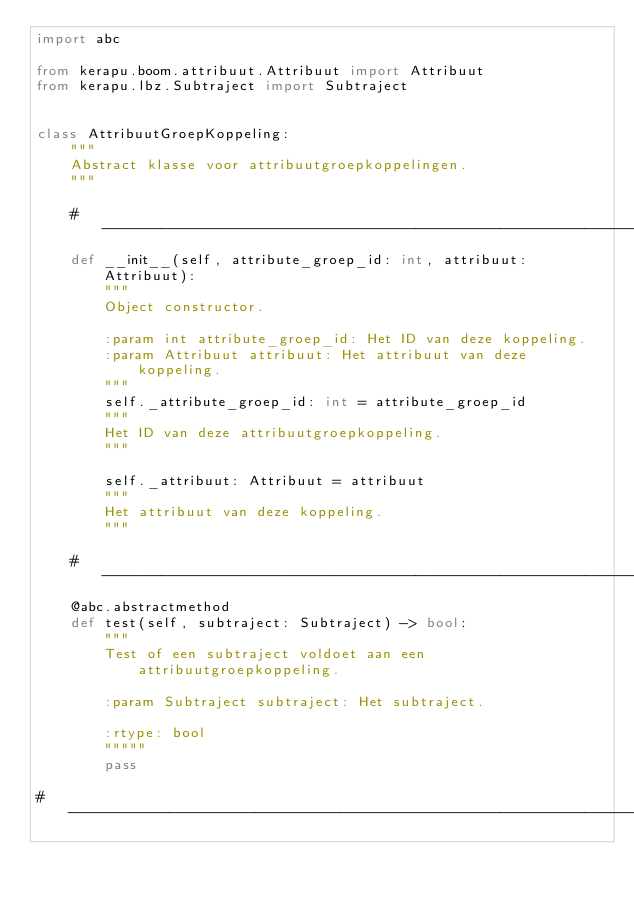Convert code to text. <code><loc_0><loc_0><loc_500><loc_500><_Python_>import abc

from kerapu.boom.attribuut.Attribuut import Attribuut
from kerapu.lbz.Subtraject import Subtraject


class AttribuutGroepKoppeling:
    """
    Abstract klasse voor attribuutgroepkoppelingen.
    """

    # ------------------------------------------------------------------------------------------------------------------
    def __init__(self, attribute_groep_id: int, attribuut: Attribuut):
        """
        Object constructor.

        :param int attribute_groep_id: Het ID van deze koppeling.
        :param Attribuut attribuut: Het attribuut van deze koppeling.
        """
        self._attribute_groep_id: int = attribute_groep_id
        """
        Het ID van deze attribuutgroepkoppeling.
        """

        self._attribuut: Attribuut = attribuut
        """
        Het attribuut van deze koppeling.
        """

    # ------------------------------------------------------------------------------------------------------------------
    @abc.abstractmethod
    def test(self, subtraject: Subtraject) -> bool:
        """
        Test of een subtraject voldoet aan een attribuutgroepkoppeling.

        :param Subtraject subtraject: Het subtraject.

        :rtype: bool
        """""
        pass

# ----------------------------------------------------------------------------------------------------------------------
</code> 